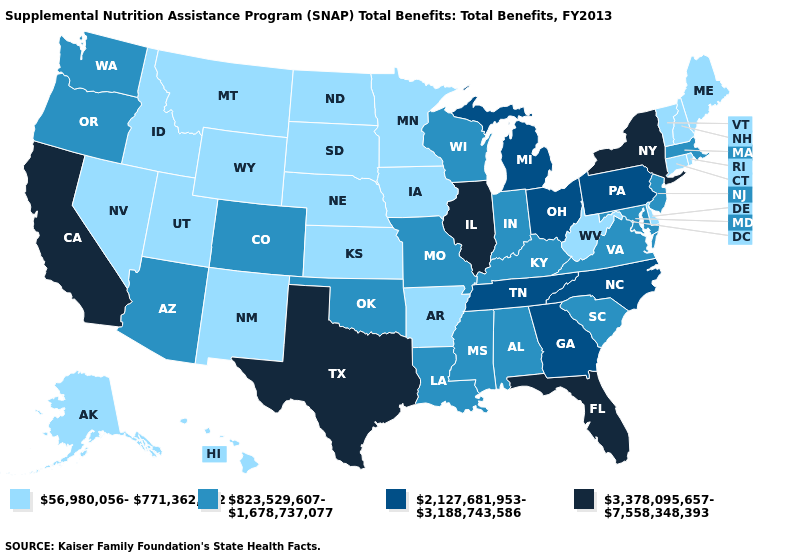Among the states that border Indiana , which have the lowest value?
Keep it brief. Kentucky. Which states have the lowest value in the USA?
Quick response, please. Alaska, Arkansas, Connecticut, Delaware, Hawaii, Idaho, Iowa, Kansas, Maine, Minnesota, Montana, Nebraska, Nevada, New Hampshire, New Mexico, North Dakota, Rhode Island, South Dakota, Utah, Vermont, West Virginia, Wyoming. What is the value of West Virginia?
Answer briefly. 56,980,056-771,362,512. What is the value of Idaho?
Quick response, please. 56,980,056-771,362,512. Does Virginia have the same value as Washington?
Write a very short answer. Yes. Which states have the lowest value in the MidWest?
Concise answer only. Iowa, Kansas, Minnesota, Nebraska, North Dakota, South Dakota. Does the first symbol in the legend represent the smallest category?
Concise answer only. Yes. Name the states that have a value in the range 2,127,681,953-3,188,743,586?
Quick response, please. Georgia, Michigan, North Carolina, Ohio, Pennsylvania, Tennessee. Which states have the highest value in the USA?
Write a very short answer. California, Florida, Illinois, New York, Texas. Which states have the highest value in the USA?
Concise answer only. California, Florida, Illinois, New York, Texas. Does Delaware have the highest value in the USA?
Quick response, please. No. What is the lowest value in states that border Delaware?
Keep it brief. 823,529,607-1,678,737,077. Which states have the lowest value in the USA?
Give a very brief answer. Alaska, Arkansas, Connecticut, Delaware, Hawaii, Idaho, Iowa, Kansas, Maine, Minnesota, Montana, Nebraska, Nevada, New Hampshire, New Mexico, North Dakota, Rhode Island, South Dakota, Utah, Vermont, West Virginia, Wyoming. Does the map have missing data?
Give a very brief answer. No. Among the states that border Colorado , does Oklahoma have the lowest value?
Give a very brief answer. No. 